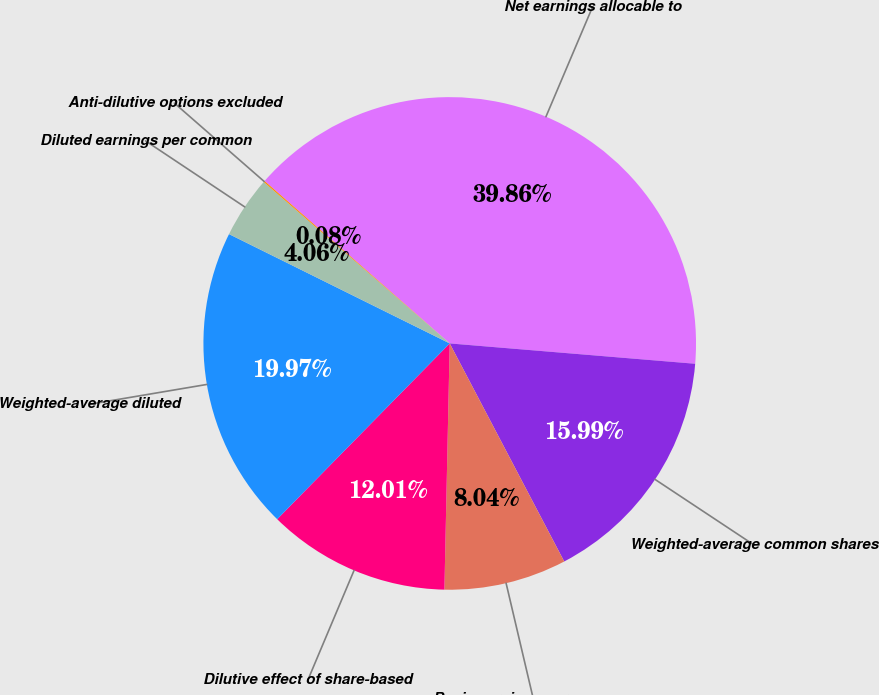Convert chart to OTSL. <chart><loc_0><loc_0><loc_500><loc_500><pie_chart><fcel>Net earnings allocable to<fcel>Weighted-average common shares<fcel>Basic earnings per common<fcel>Dilutive effect of share-based<fcel>Weighted-average diluted<fcel>Diluted earnings per common<fcel>Anti-dilutive options excluded<nl><fcel>39.86%<fcel>15.99%<fcel>8.04%<fcel>12.01%<fcel>19.97%<fcel>4.06%<fcel>0.08%<nl></chart> 